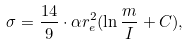<formula> <loc_0><loc_0><loc_500><loc_500>\sigma = \frac { 1 4 } { 9 } \cdot \alpha r _ { e } ^ { 2 } ( \ln \frac { m } { I } + C ) ,</formula> 